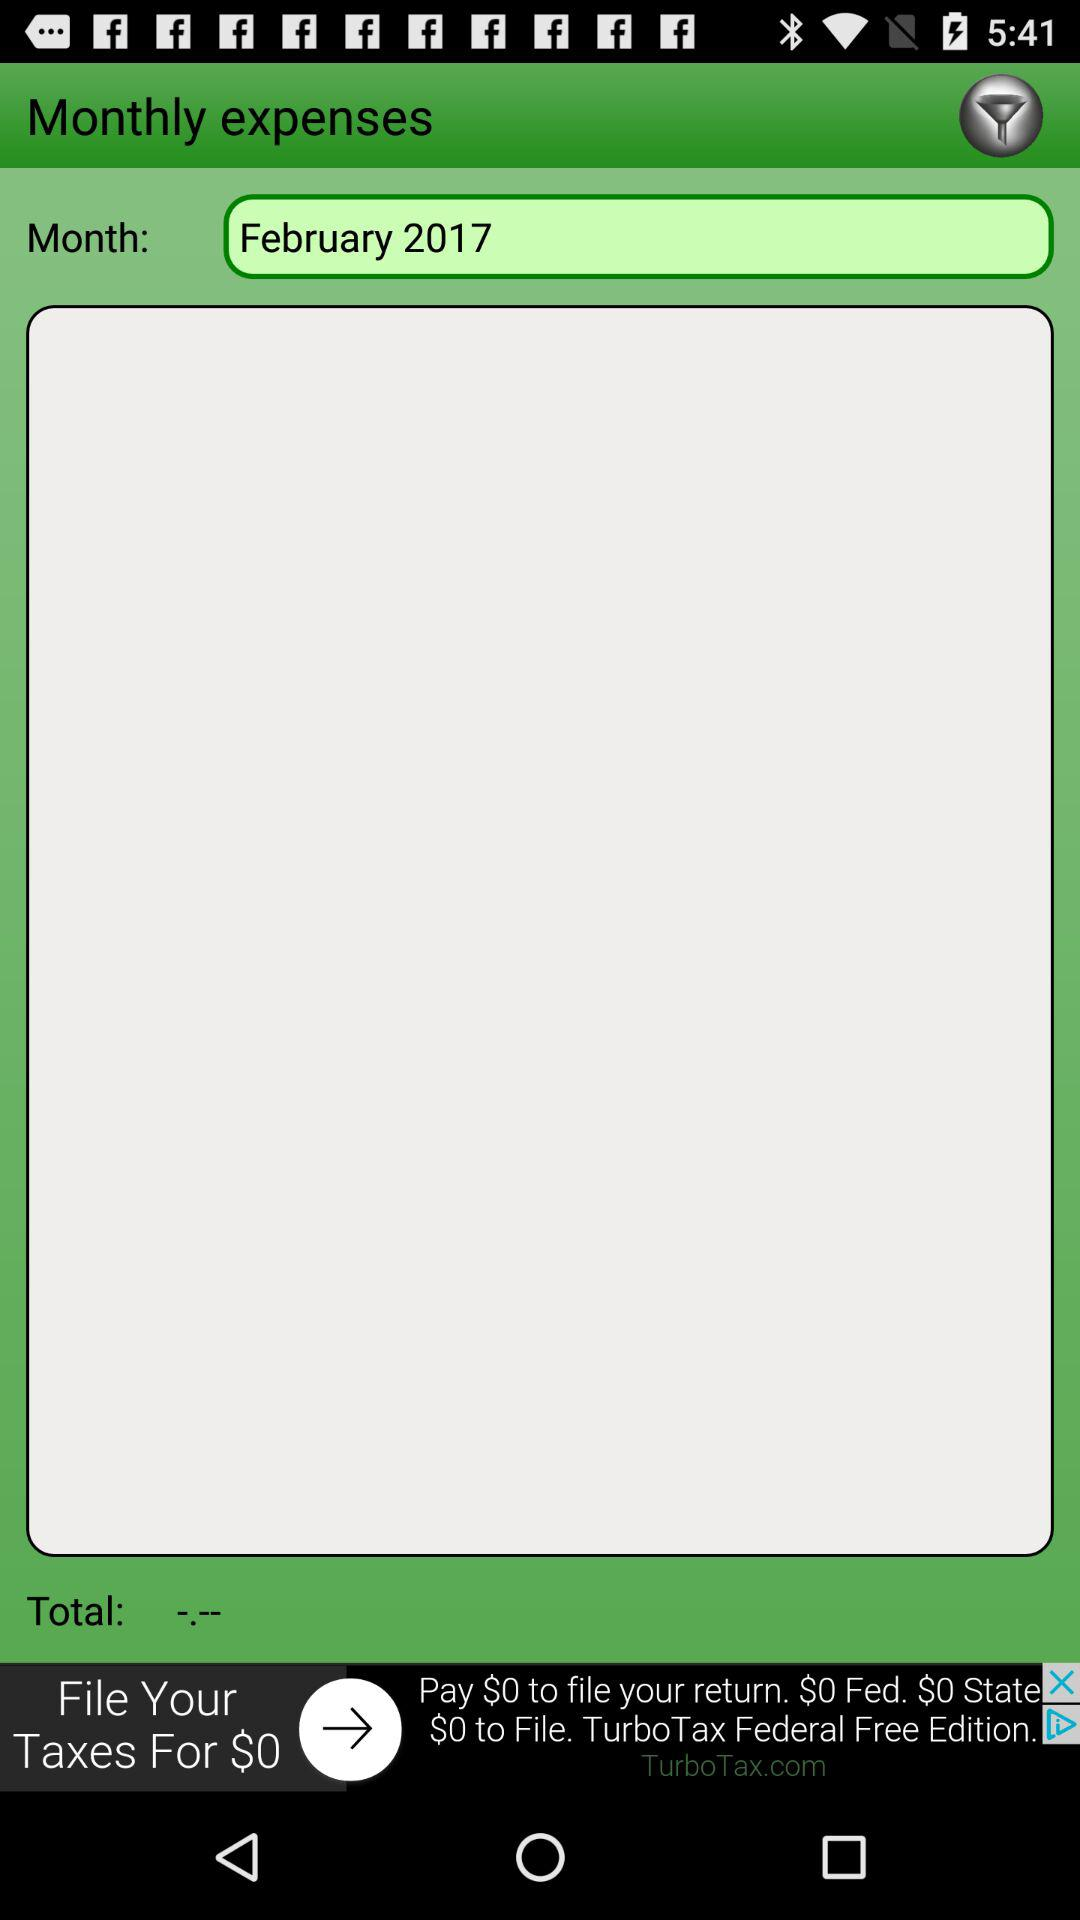What is the month? The month is February. 